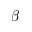<formula> <loc_0><loc_0><loc_500><loc_500>\beta</formula> 